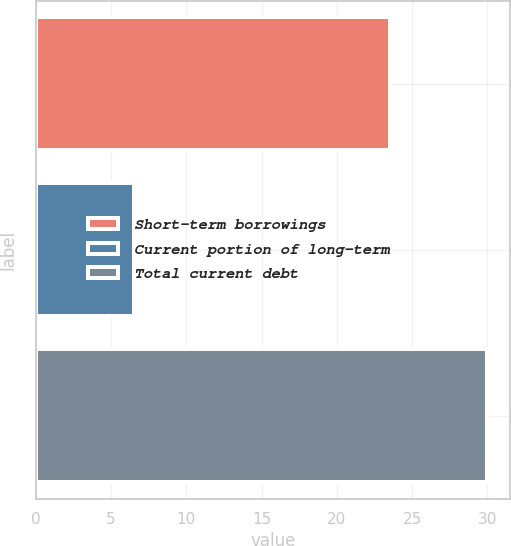Convert chart. <chart><loc_0><loc_0><loc_500><loc_500><bar_chart><fcel>Short-term borrowings<fcel>Current portion of long-term<fcel>Total current debt<nl><fcel>23.5<fcel>6.5<fcel>30<nl></chart> 